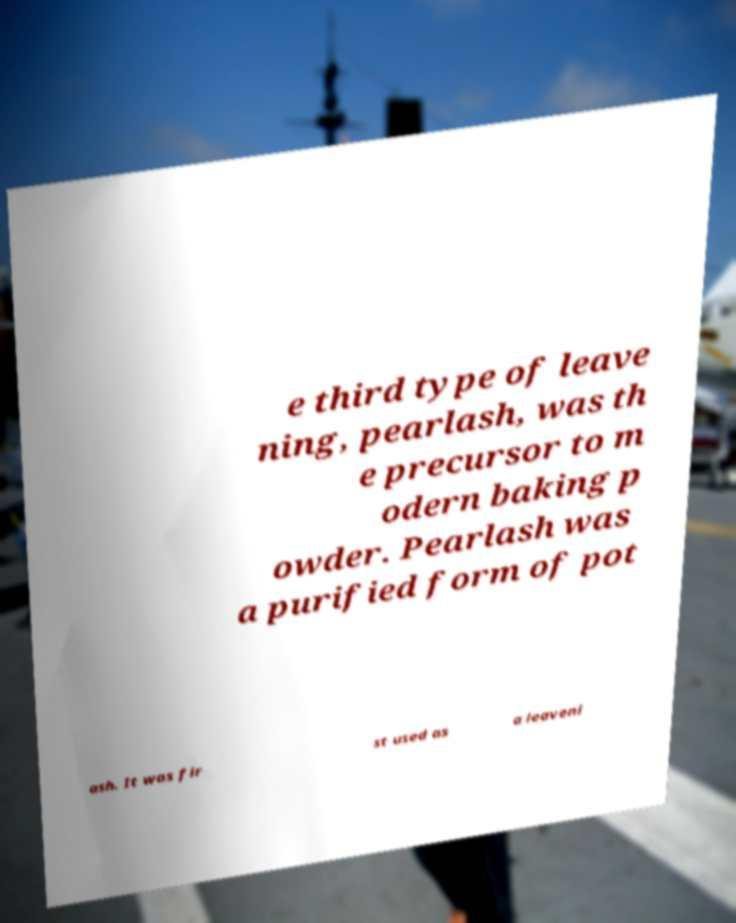Can you accurately transcribe the text from the provided image for me? e third type of leave ning, pearlash, was th e precursor to m odern baking p owder. Pearlash was a purified form of pot ash. It was fir st used as a leaveni 